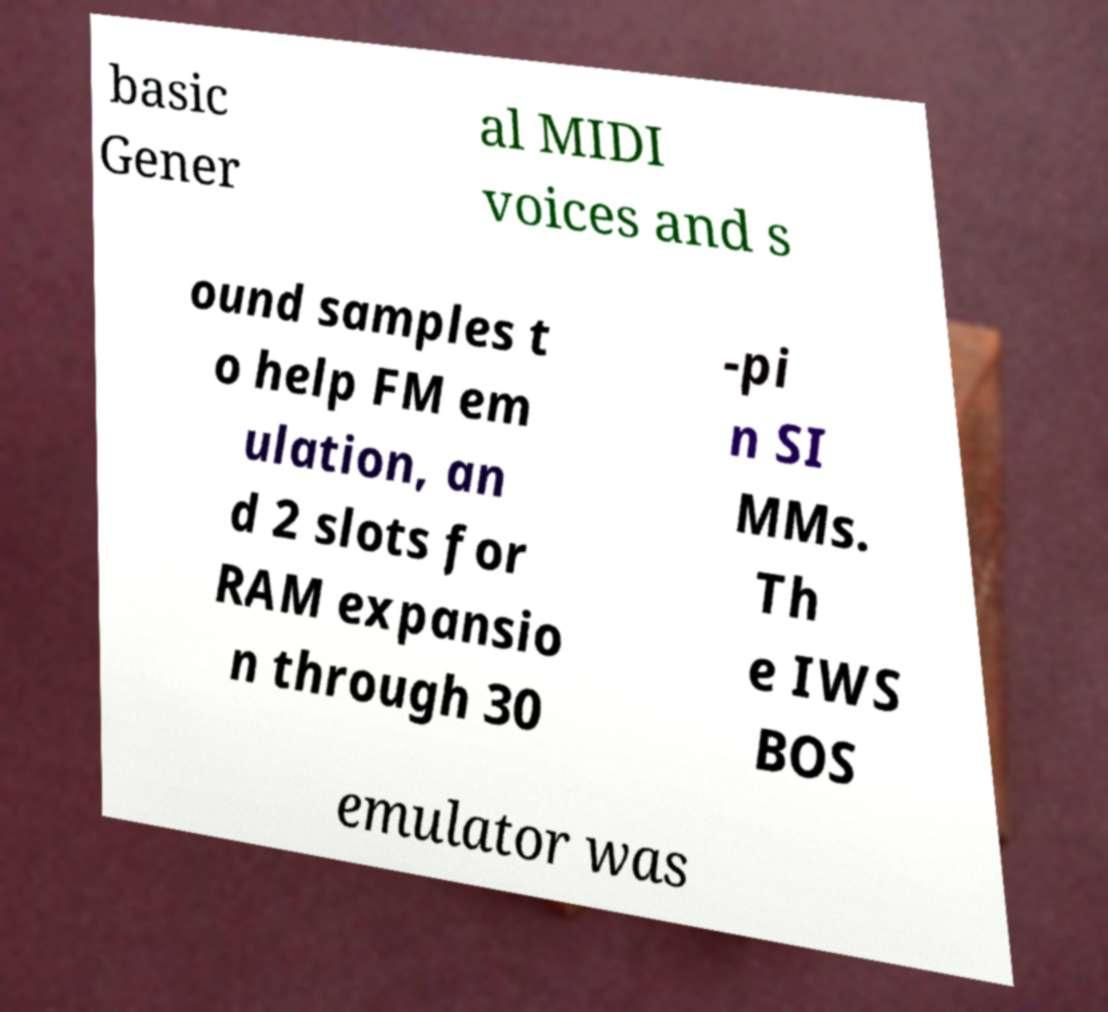Could you assist in decoding the text presented in this image and type it out clearly? basic Gener al MIDI voices and s ound samples t o help FM em ulation, an d 2 slots for RAM expansio n through 30 -pi n SI MMs. Th e IWS BOS emulator was 